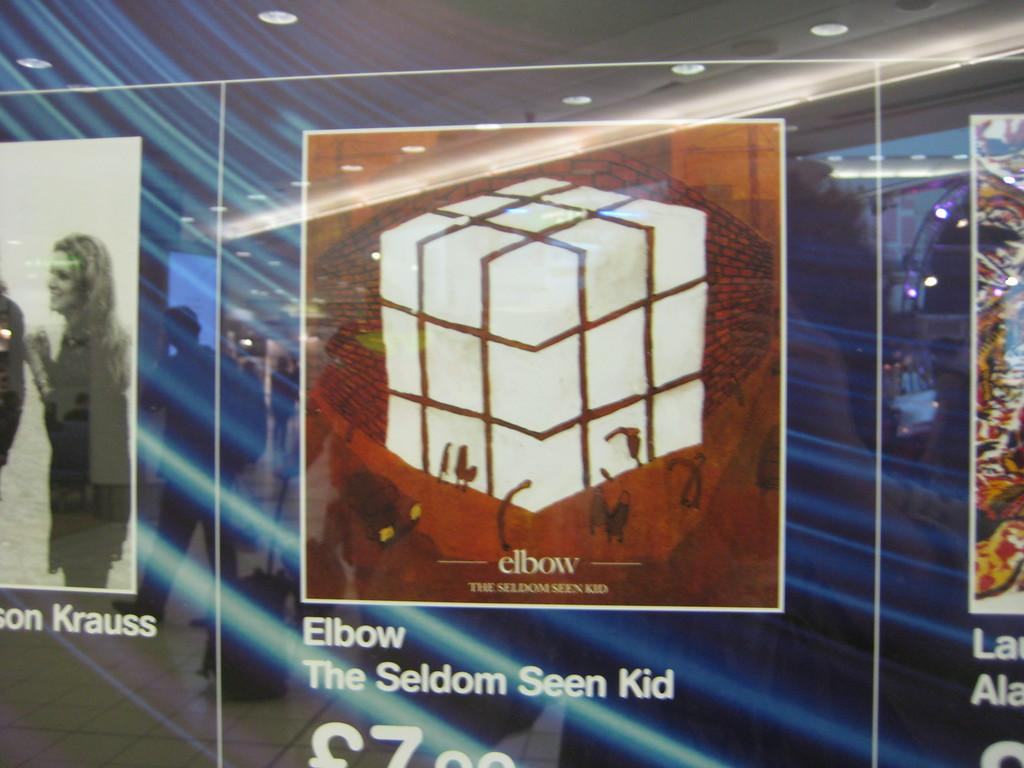<image>
Create a compact narrative representing the image presented. A drawing of a rubik's cube is shown on an ad for Elbow. 